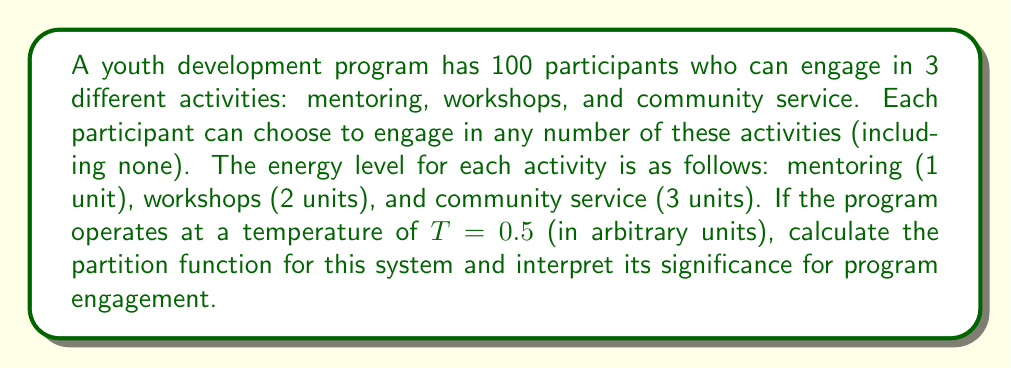Show me your answer to this math problem. To solve this problem, we'll follow these steps:

1) First, let's recall the formula for the partition function:

   $$Z = \sum_{i} e^{-\beta E_i}$$

   where $\beta = \frac{1}{k_B T}$, $k_B$ is Boltzmann's constant (which we'll assume to be 1 in this case), and $E_i$ are the energy levels.

2) In this case, we have 4 possible states for each participant:
   - No activity: $E_0 = 0$
   - Mentoring: $E_1 = 1$
   - Workshops: $E_2 = 2$
   - Community service: $E_3 = 3$

3) The partition function for a single participant is:

   $$Z_1 = e^{-\beta \cdot 0} + e^{-\beta \cdot 1} + e^{-\beta \cdot 2} + e^{-\beta \cdot 3}$$

4) Substituting $\beta = \frac{1}{T} = \frac{1}{0.5} = 2$:

   $$Z_1 = 1 + e^{-2} + e^{-4} + e^{-6}$$

5) Calculate this:

   $$Z_1 \approx 1 + 0.1353 + 0.0183 + 0.0025 \approx 1.1561$$

6) For 100 independent participants, the total partition function is:

   $$Z = (Z_1)^{100} \approx (1.1561)^{100} \approx 3.43 \times 10^6$$

7) Interpretation: The partition function represents the total number of possible microstates in the system. A larger value indicates more possible configurations and higher entropy, suggesting a more engaged and diverse program. The exponential growth with the number of participants highlights the potential for diverse engagement patterns in larger programs.
Answer: $Z \approx 3.43 \times 10^6$ 